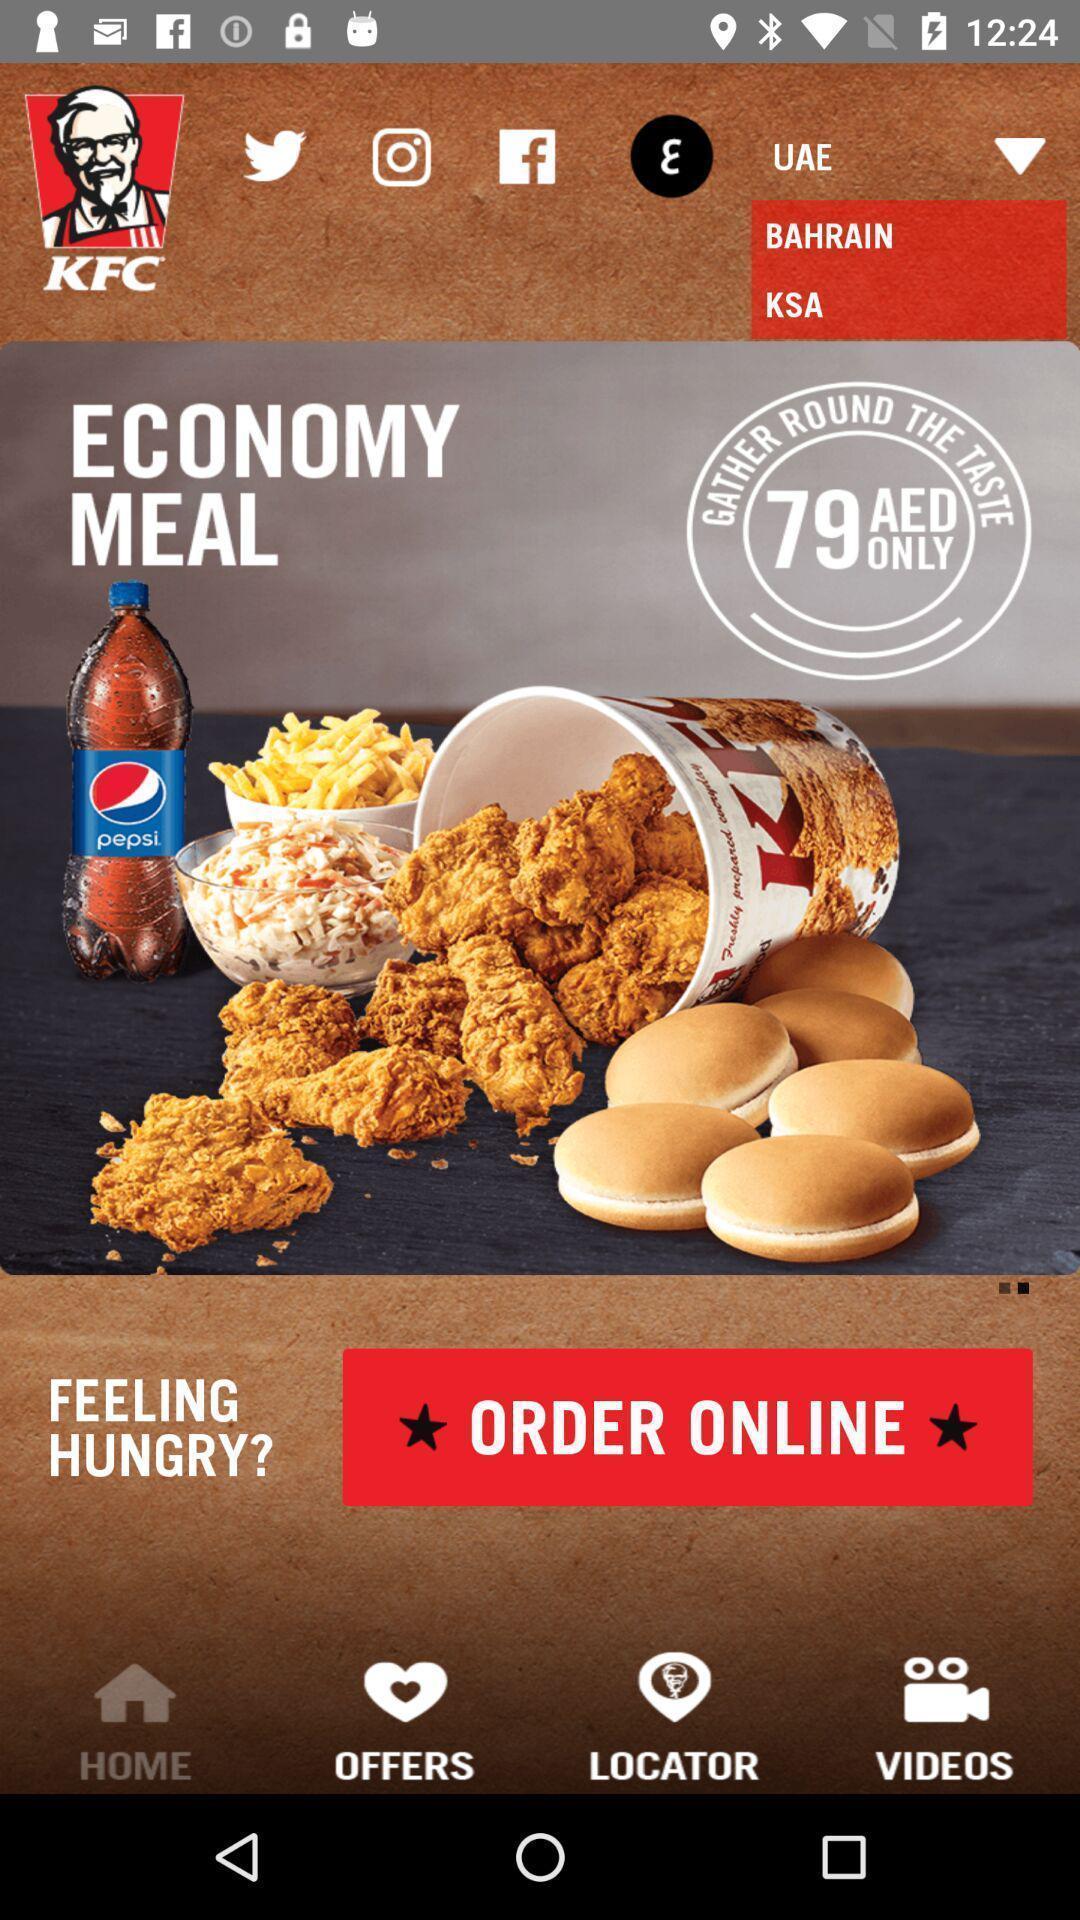Give me a narrative description of this picture. Page with multiple options of an food app. 